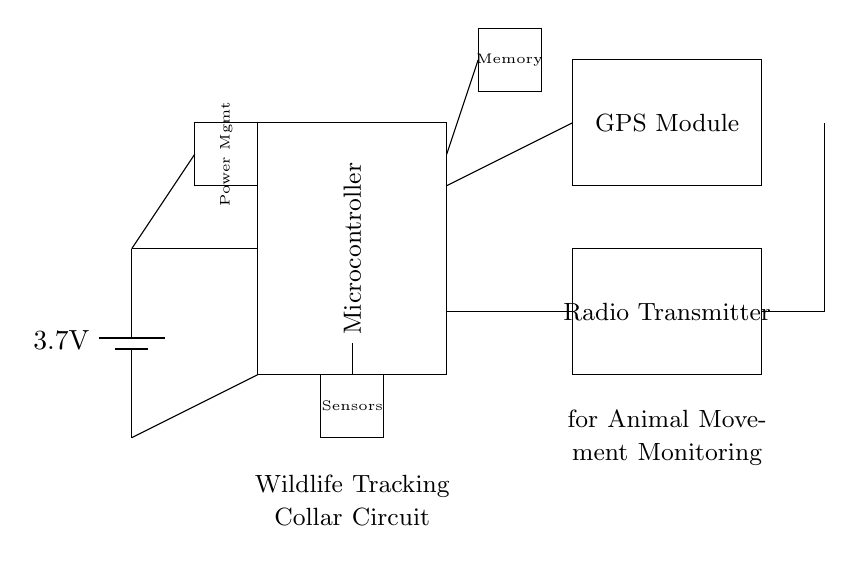What is the voltage of the power source? The voltage of the battery in the circuit is labeled as 3.7V. This can be seen in the section of the diagram where the battery component is drawn.
Answer: 3.7V What are the main components of this circuit? The main components of the circuit include a battery, microcontroller, GPS module, radio transmitter, power management unit, sensors, memory module, and an antenna. Each component is rectangularly represented in the diagram, and each is labeled accordingly.
Answer: Battery, Microcontroller, GPS Module, Radio Transmitter, Power Management, Sensors, Memory, Antenna Which component handles data storage? The component that handles data storage is the memory module, which is represented as a rectangle in the circuit. It is labeled 'Memory' and is connected to the microcontroller, which suggests its role in storing data.
Answer: Memory How does the GPS module connect to the microcontroller? The GPS module connects to the microcontroller via a wire that extends from the microcontroller to the upper side of the GPS module. This top connection indicates that the GPS module provides data to the microcontroller, which processes the information.
Answer: Through a direct wire connection What is the function of the radio transmitter in this circuit? The radio transmitter's function in this circuit is to send data wirelessly, likely the location and movement data obtained from the GPS module, to a remote receiver. This can be inferred from its placement and connections in the circuit schema.
Answer: To transmit data wirelessly How are the components powered in this circuit? The components are powered by the 3.7V battery, which connects to the power management unit and distributes power to the microcontroller and other components. The battery provides the necessary voltage for operation, as shown in the circuit connections.
Answer: Through the power management unit connected to the battery 